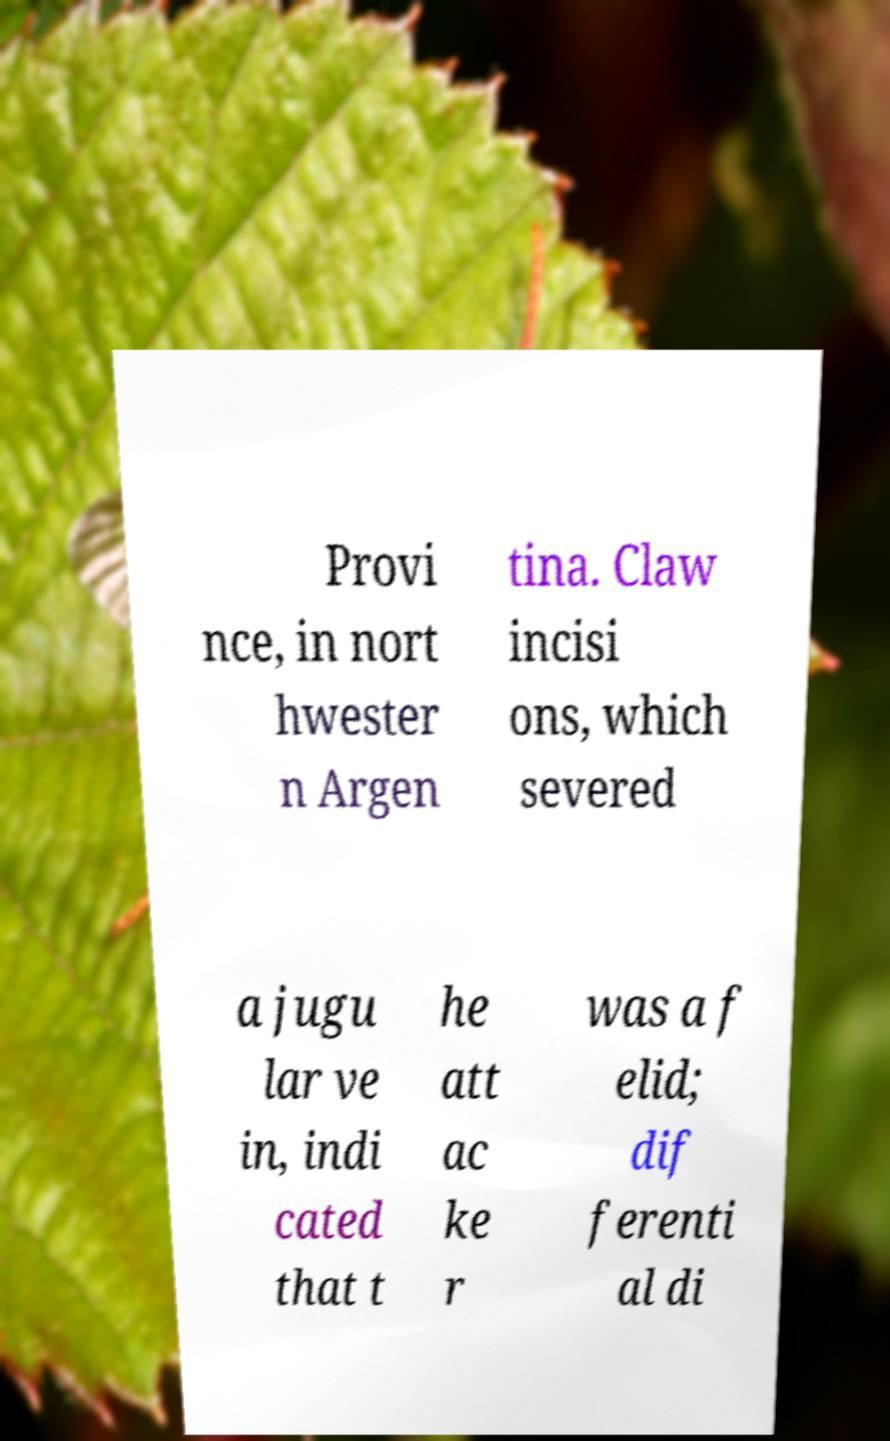Could you extract and type out the text from this image? Provi nce, in nort hwester n Argen tina. Claw incisi ons, which severed a jugu lar ve in, indi cated that t he att ac ke r was a f elid; dif ferenti al di 